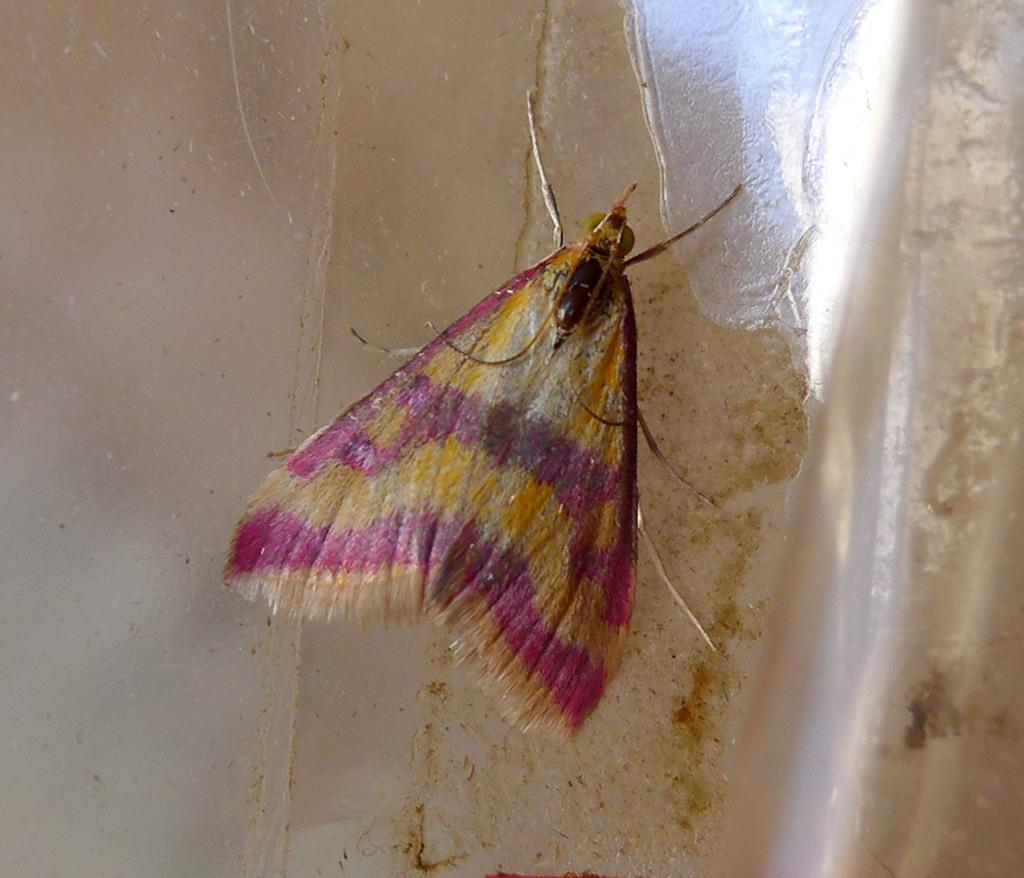What is present in the picture? There is a fly in the picture. Where is the fly located? The fly is on the wall. What colors can be seen on the fly? The fly has white, brown, and pink colors. What type of current is flowing through the thread in the image? There is no thread or current present in the image; it features a fly on the wall. What stage of development can be observed in the fly in the image? The provided facts do not give information about the fly's development stage. 